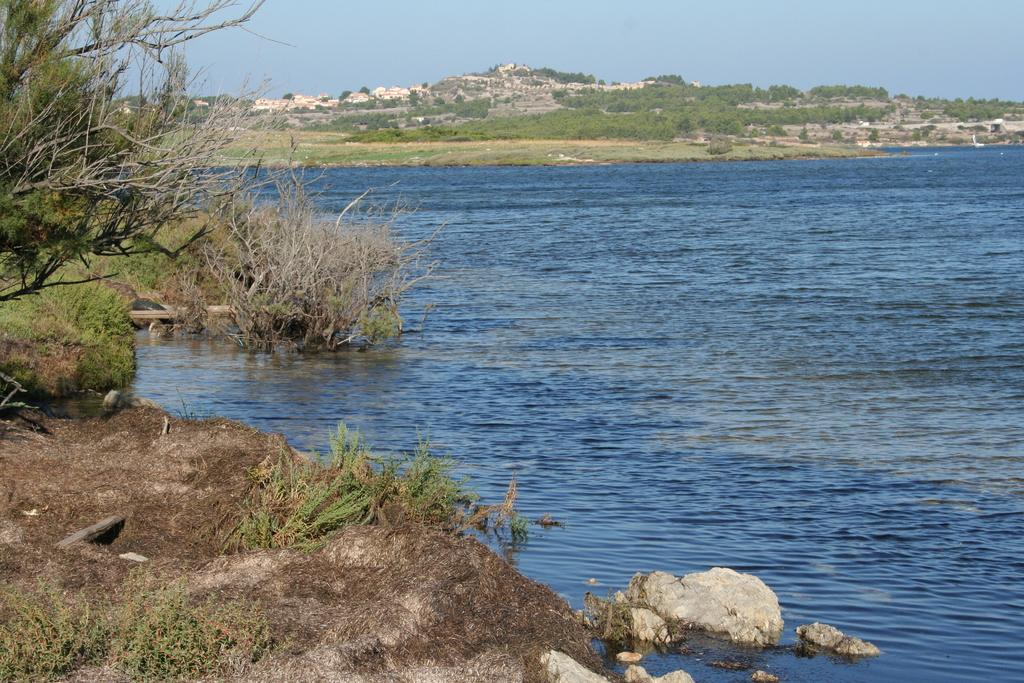What body of water is present in the image? There is a lake in the image. What can be found near the lake? There are plants on the ground near the lake. What type of vegetation is visible in the background of the image? There are many trees visible in the background of the image. How many fish can be seen wearing masks in the image? There are no fish or masks present in the image. 